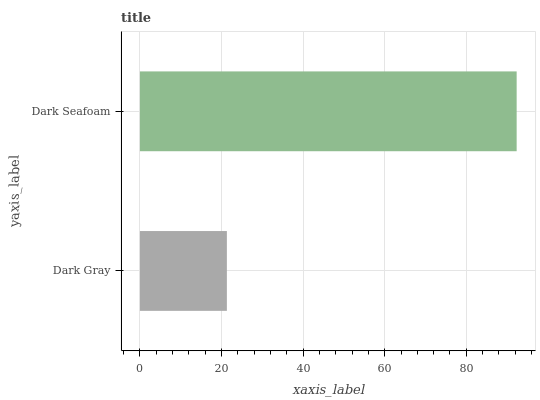Is Dark Gray the minimum?
Answer yes or no. Yes. Is Dark Seafoam the maximum?
Answer yes or no. Yes. Is Dark Seafoam the minimum?
Answer yes or no. No. Is Dark Seafoam greater than Dark Gray?
Answer yes or no. Yes. Is Dark Gray less than Dark Seafoam?
Answer yes or no. Yes. Is Dark Gray greater than Dark Seafoam?
Answer yes or no. No. Is Dark Seafoam less than Dark Gray?
Answer yes or no. No. Is Dark Seafoam the high median?
Answer yes or no. Yes. Is Dark Gray the low median?
Answer yes or no. Yes. Is Dark Gray the high median?
Answer yes or no. No. Is Dark Seafoam the low median?
Answer yes or no. No. 